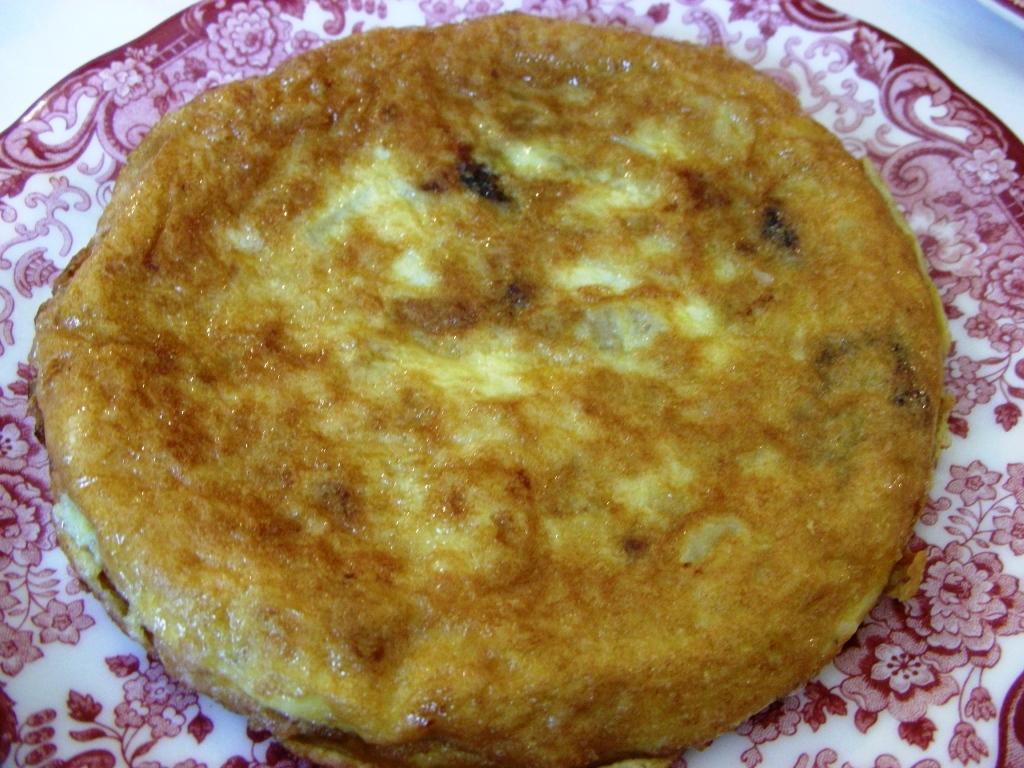In one or two sentences, can you explain what this image depicts? In the image I can see a plate in which there is some food item. 